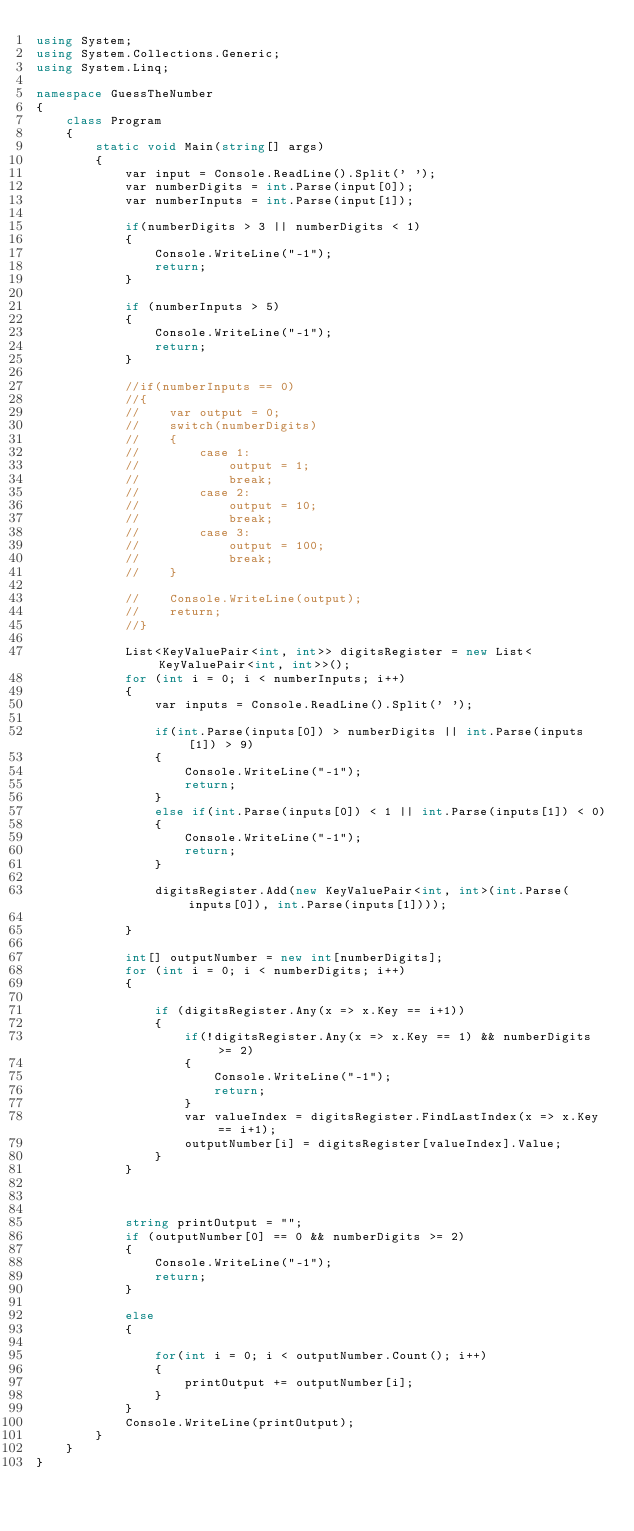Convert code to text. <code><loc_0><loc_0><loc_500><loc_500><_C#_>using System;
using System.Collections.Generic;
using System.Linq;

namespace GuessTheNumber
{
    class Program
    {
        static void Main(string[] args)
        {
            var input = Console.ReadLine().Split(' ');
            var numberDigits = int.Parse(input[0]);
            var numberInputs = int.Parse(input[1]);

            if(numberDigits > 3 || numberDigits < 1)
            {
                Console.WriteLine("-1");
                return;
            }

            if (numberInputs > 5)
            {
                Console.WriteLine("-1");
                return;
            }

            //if(numberInputs == 0)
            //{
            //    var output = 0;
            //    switch(numberDigits)
            //    {
            //        case 1:
            //            output = 1;
            //            break;
            //        case 2:
            //            output = 10;
            //            break;
            //        case 3:
            //            output = 100;
            //            break;
            //    }

            //    Console.WriteLine(output);
            //    return;                  
            //}

            List<KeyValuePair<int, int>> digitsRegister = new List<KeyValuePair<int, int>>();
            for (int i = 0; i < numberInputs; i++)
            {
                var inputs = Console.ReadLine().Split(' ');
                
                if(int.Parse(inputs[0]) > numberDigits || int.Parse(inputs[1]) > 9)
                {
                    Console.WriteLine("-1");
                    return;
                }
                else if(int.Parse(inputs[0]) < 1 || int.Parse(inputs[1]) < 0)
                {
                    Console.WriteLine("-1");
                    return;
                }
                                
                digitsRegister.Add(new KeyValuePair<int, int>(int.Parse(inputs[0]), int.Parse(inputs[1])));

            }

            int[] outputNumber = new int[numberDigits];
            for (int i = 0; i < numberDigits; i++)
            {
                
                if (digitsRegister.Any(x => x.Key == i+1))
                {
                    if(!digitsRegister.Any(x => x.Key == 1) && numberDigits >= 2)
                    {
                        Console.WriteLine("-1");
                        return;
                    }
                    var valueIndex = digitsRegister.FindLastIndex(x => x.Key == i+1);
                    outputNumber[i] = digitsRegister[valueIndex].Value;
                }
            }



            string printOutput = "";
            if (outputNumber[0] == 0 && numberDigits >= 2)
            {
                Console.WriteLine("-1");
                return;
            }

            else
            {
                
                for(int i = 0; i < outputNumber.Count(); i++)
                {
                    printOutput += outputNumber[i];
                }
            }
            Console.WriteLine(printOutput);
        }
    }
}
</code> 